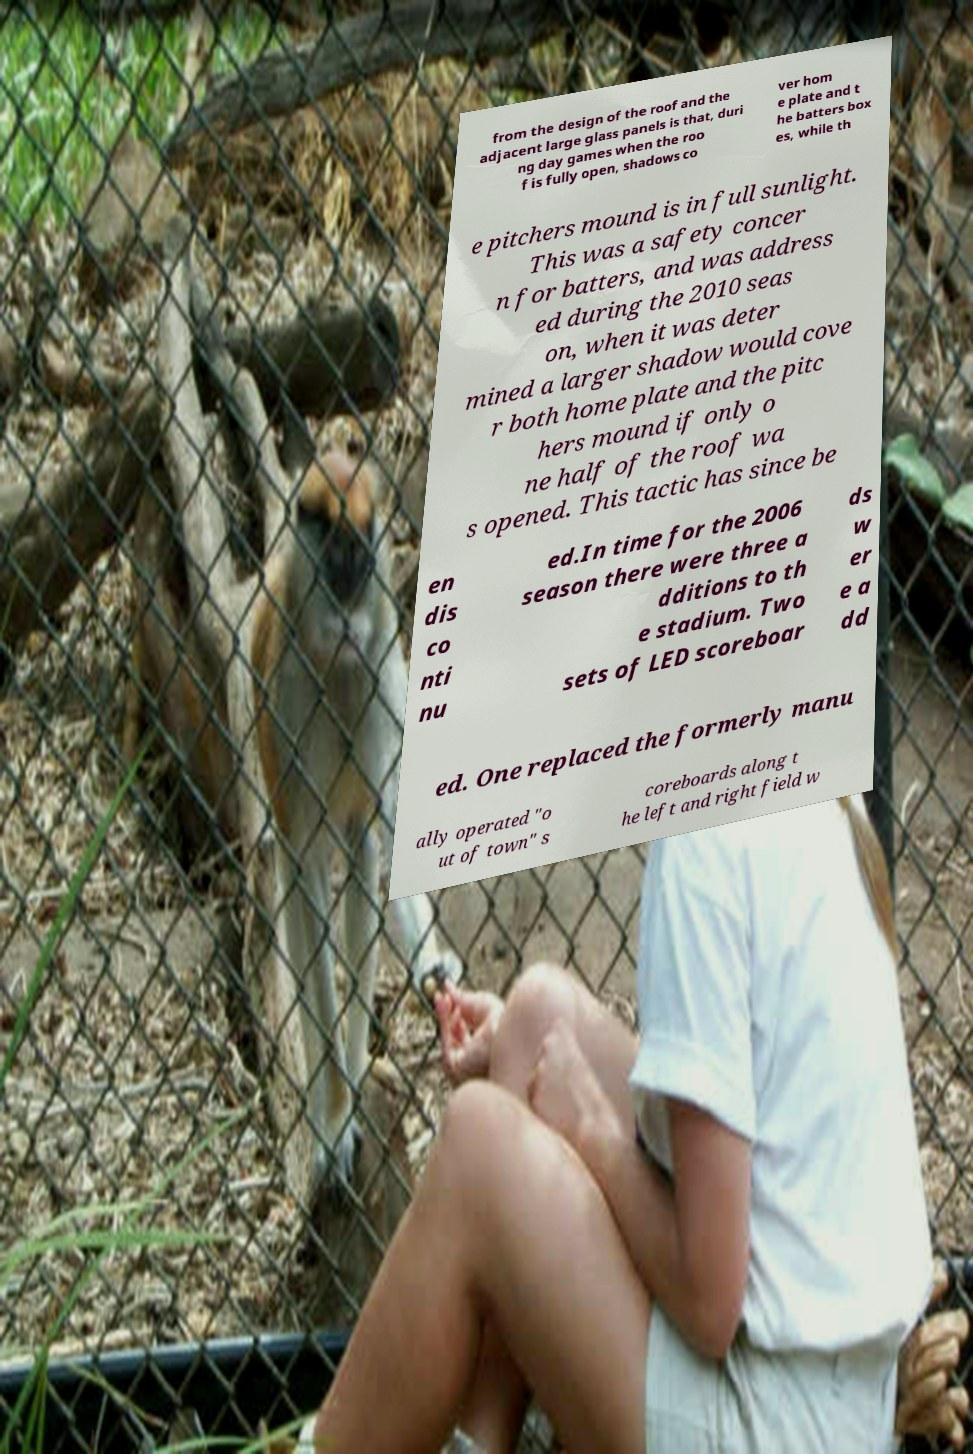What messages or text are displayed in this image? I need them in a readable, typed format. from the design of the roof and the adjacent large glass panels is that, duri ng day games when the roo f is fully open, shadows co ver hom e plate and t he batters box es, while th e pitchers mound is in full sunlight. This was a safety concer n for batters, and was address ed during the 2010 seas on, when it was deter mined a larger shadow would cove r both home plate and the pitc hers mound if only o ne half of the roof wa s opened. This tactic has since be en dis co nti nu ed.In time for the 2006 season there were three a dditions to th e stadium. Two sets of LED scoreboar ds w er e a dd ed. One replaced the formerly manu ally operated "o ut of town" s coreboards along t he left and right field w 